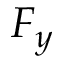<formula> <loc_0><loc_0><loc_500><loc_500>F _ { y }</formula> 